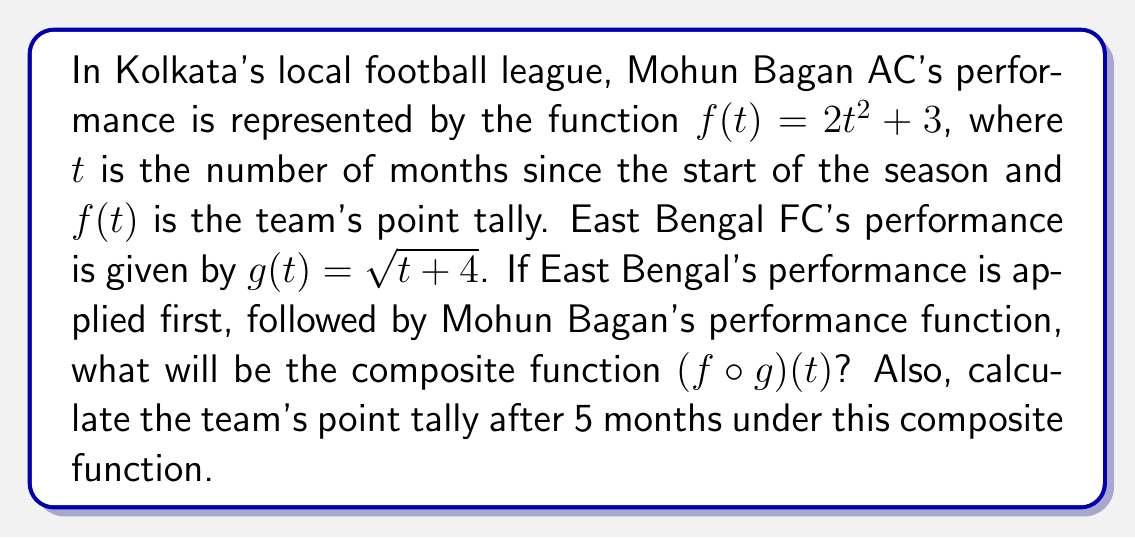Provide a solution to this math problem. To solve this problem, we need to follow these steps:

1) The composition of functions $f(g(t))$ is denoted as $(f \circ g)(t)$.

2) We start with the inner function $g(t) = \sqrt{t+4}$.

3) We then apply the outer function $f(t) = 2t^2 + 3$, replacing $t$ with $g(t)$:

   $$(f \circ g)(t) = f(g(t)) = 2(g(t))^2 + 3$$

4) Substituting $g(t) = \sqrt{t+4}$:

   $$(f \circ g)(t) = 2(\sqrt{t+4})^2 + 3$$

5) Simplify:
   $$(f \circ g)(t) = 2(t+4) + 3 = 2t + 8 + 3 = 2t + 11$$

6) Therefore, the composite function is $(f \circ g)(t) = 2t + 11$.

7) To calculate the point tally after 5 months, we substitute $t = 5$ into the composite function:

   $$(f \circ g)(5) = 2(5) + 11 = 10 + 11 = 21$$
Answer: $(f \circ g)(t) = 2t + 11$; Point tally after 5 months: 21 